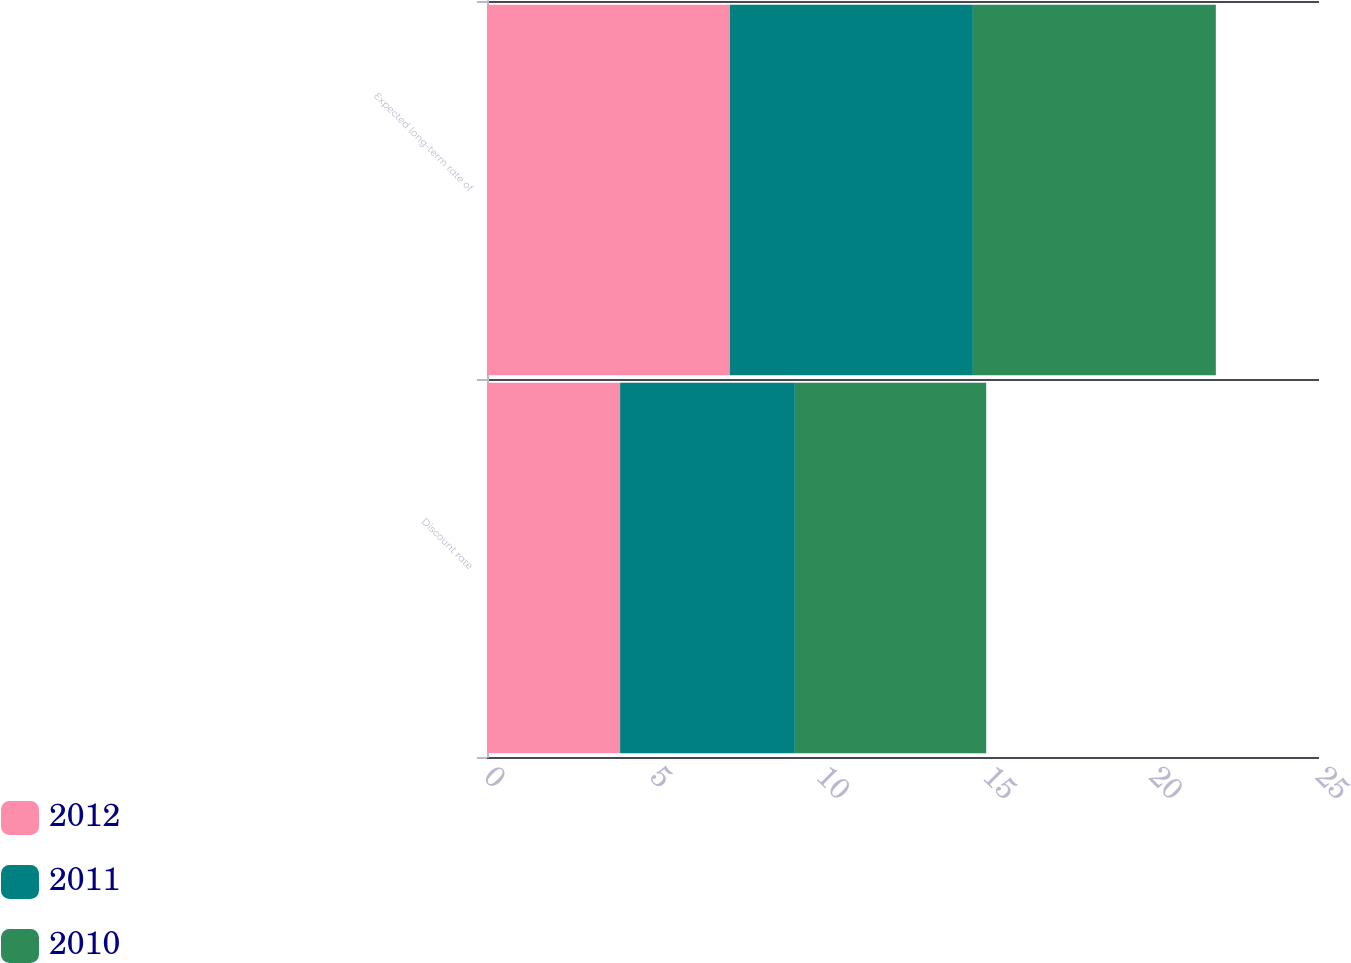Convert chart. <chart><loc_0><loc_0><loc_500><loc_500><stacked_bar_chart><ecel><fcel>Discount rate<fcel>Expected long-term rate of<nl><fcel>2012<fcel>4<fcel>7.3<nl><fcel>2011<fcel>5.25<fcel>7.3<nl><fcel>2010<fcel>5.75<fcel>7.3<nl></chart> 